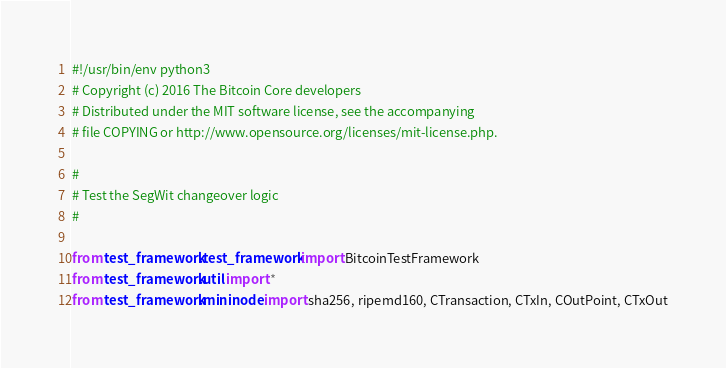Convert code to text. <code><loc_0><loc_0><loc_500><loc_500><_Python_>#!/usr/bin/env python3
# Copyright (c) 2016 The Bitcoin Core developers
# Distributed under the MIT software license, see the accompanying
# file COPYING or http://www.opensource.org/licenses/mit-license.php.

#
# Test the SegWit changeover logic
#

from test_framework.test_framework import BitcoinTestFramework
from test_framework.util import *
from test_framework.mininode import sha256, ripemd160, CTransaction, CTxIn, COutPoint, CTxOut</code> 